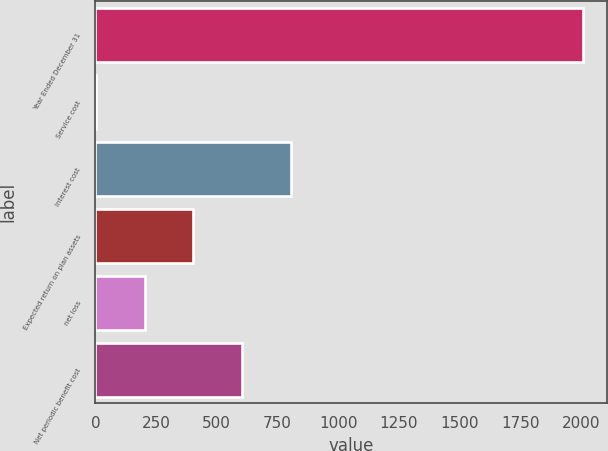Convert chart to OTSL. <chart><loc_0><loc_0><loc_500><loc_500><bar_chart><fcel>Year Ended December 31<fcel>Service cost<fcel>Interest cost<fcel>Expected return on plan assets<fcel>net loss<fcel>Net periodic benefit cost<nl><fcel>2007<fcel>3<fcel>804.6<fcel>403.8<fcel>203.4<fcel>604.2<nl></chart> 